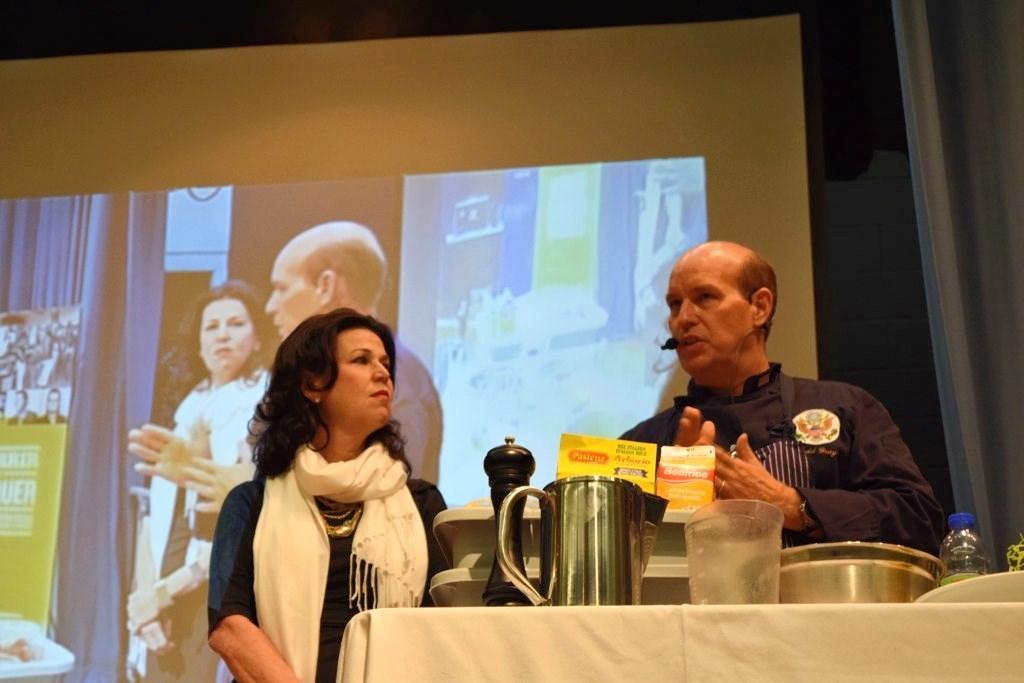Describe this image in one or two sentences. In the picture we can see a man wearing apron and a woman wearing dress and scarf are standing here where we can see a table in front of them. Here we can see some objects are placed on the table. In the background, we can see the projector screen on which we can see these two persons are displayed. 